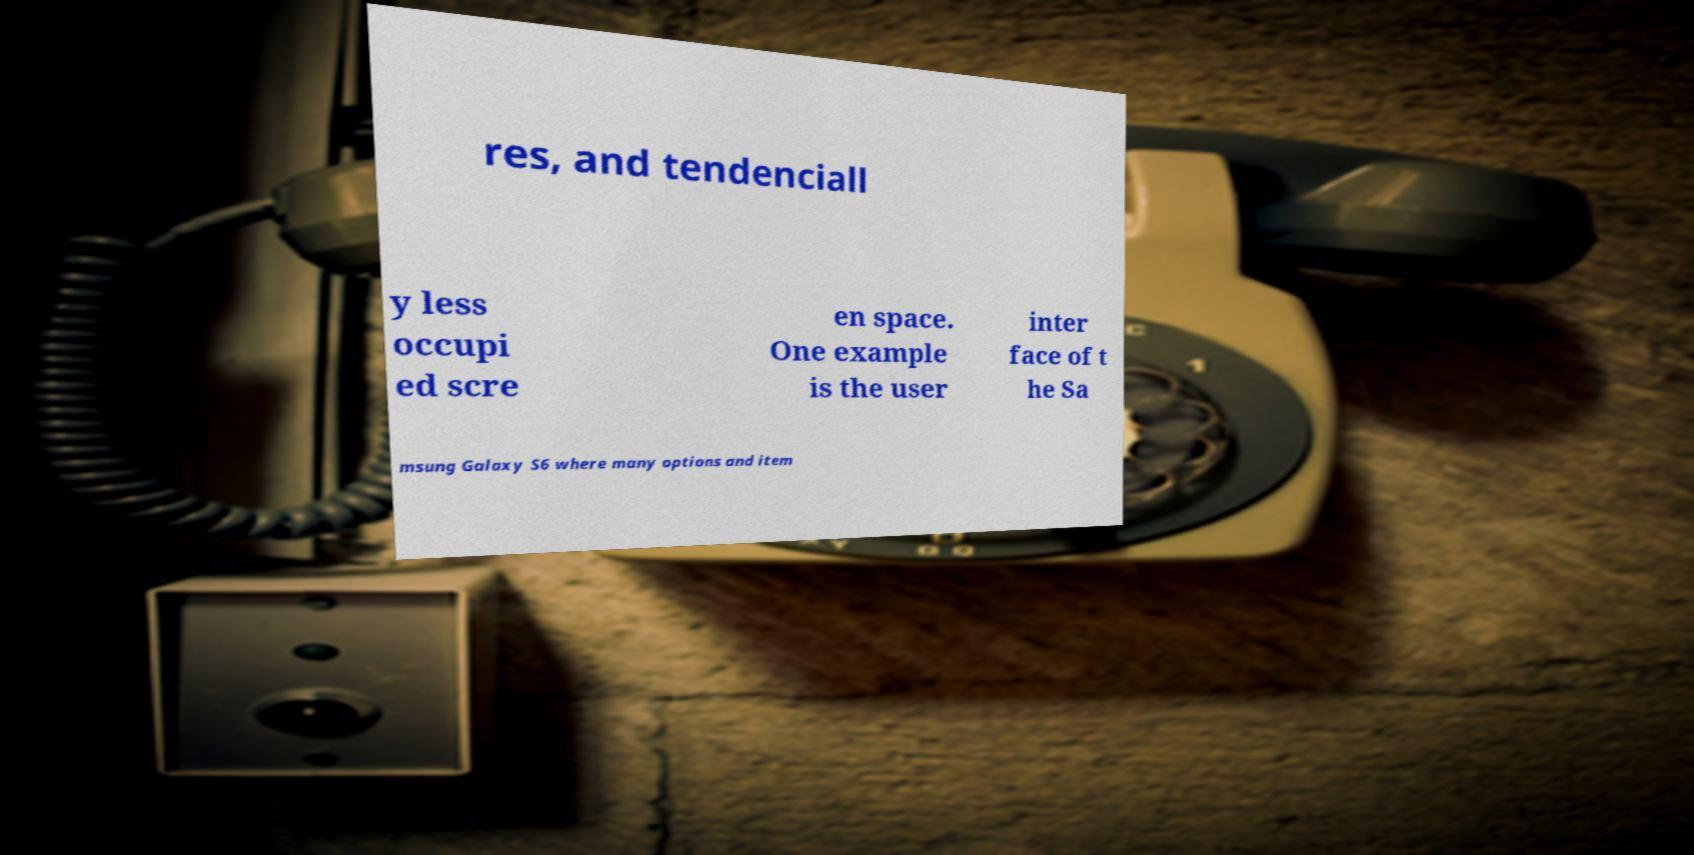What messages or text are displayed in this image? I need them in a readable, typed format. res, and tendenciall y less occupi ed scre en space. One example is the user inter face of t he Sa msung Galaxy S6 where many options and item 